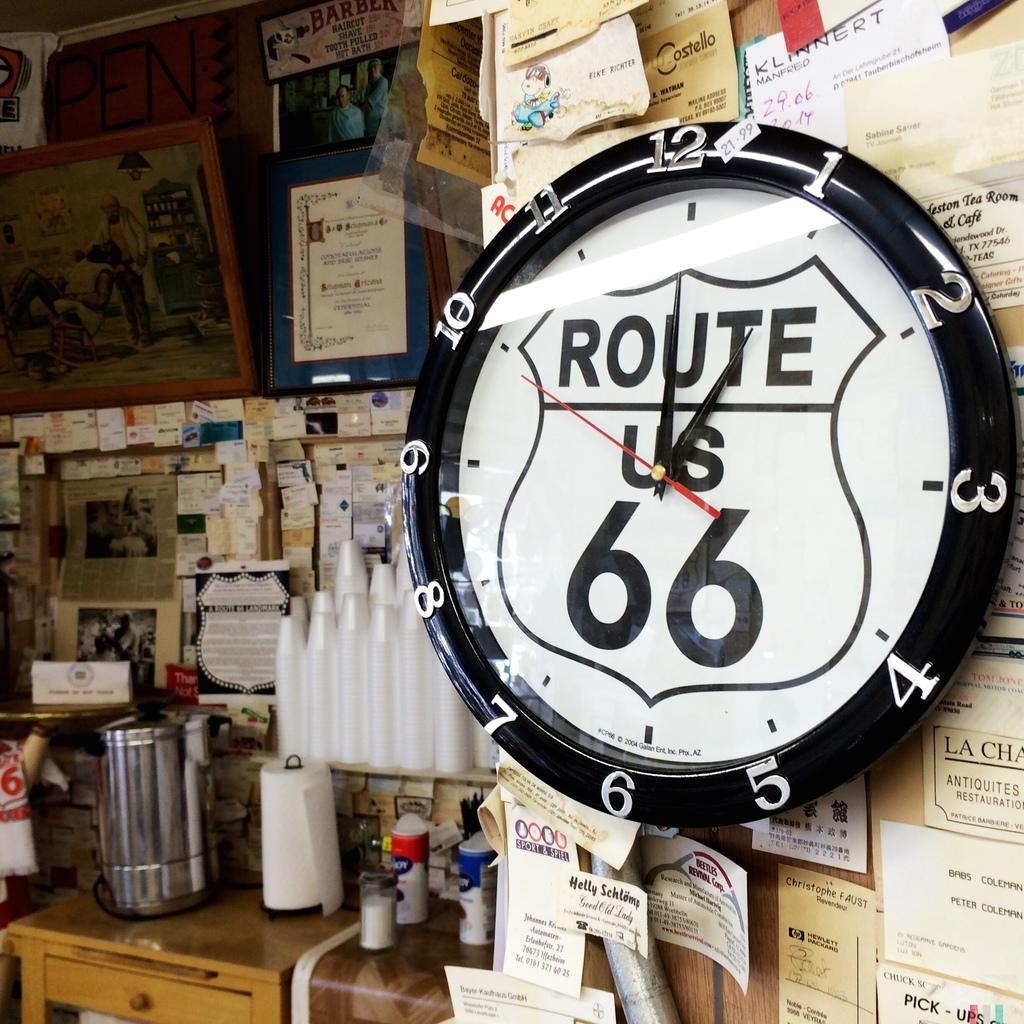<image>
Render a clear and concise summary of the photo. A clock has Route US 66 printed on it. 